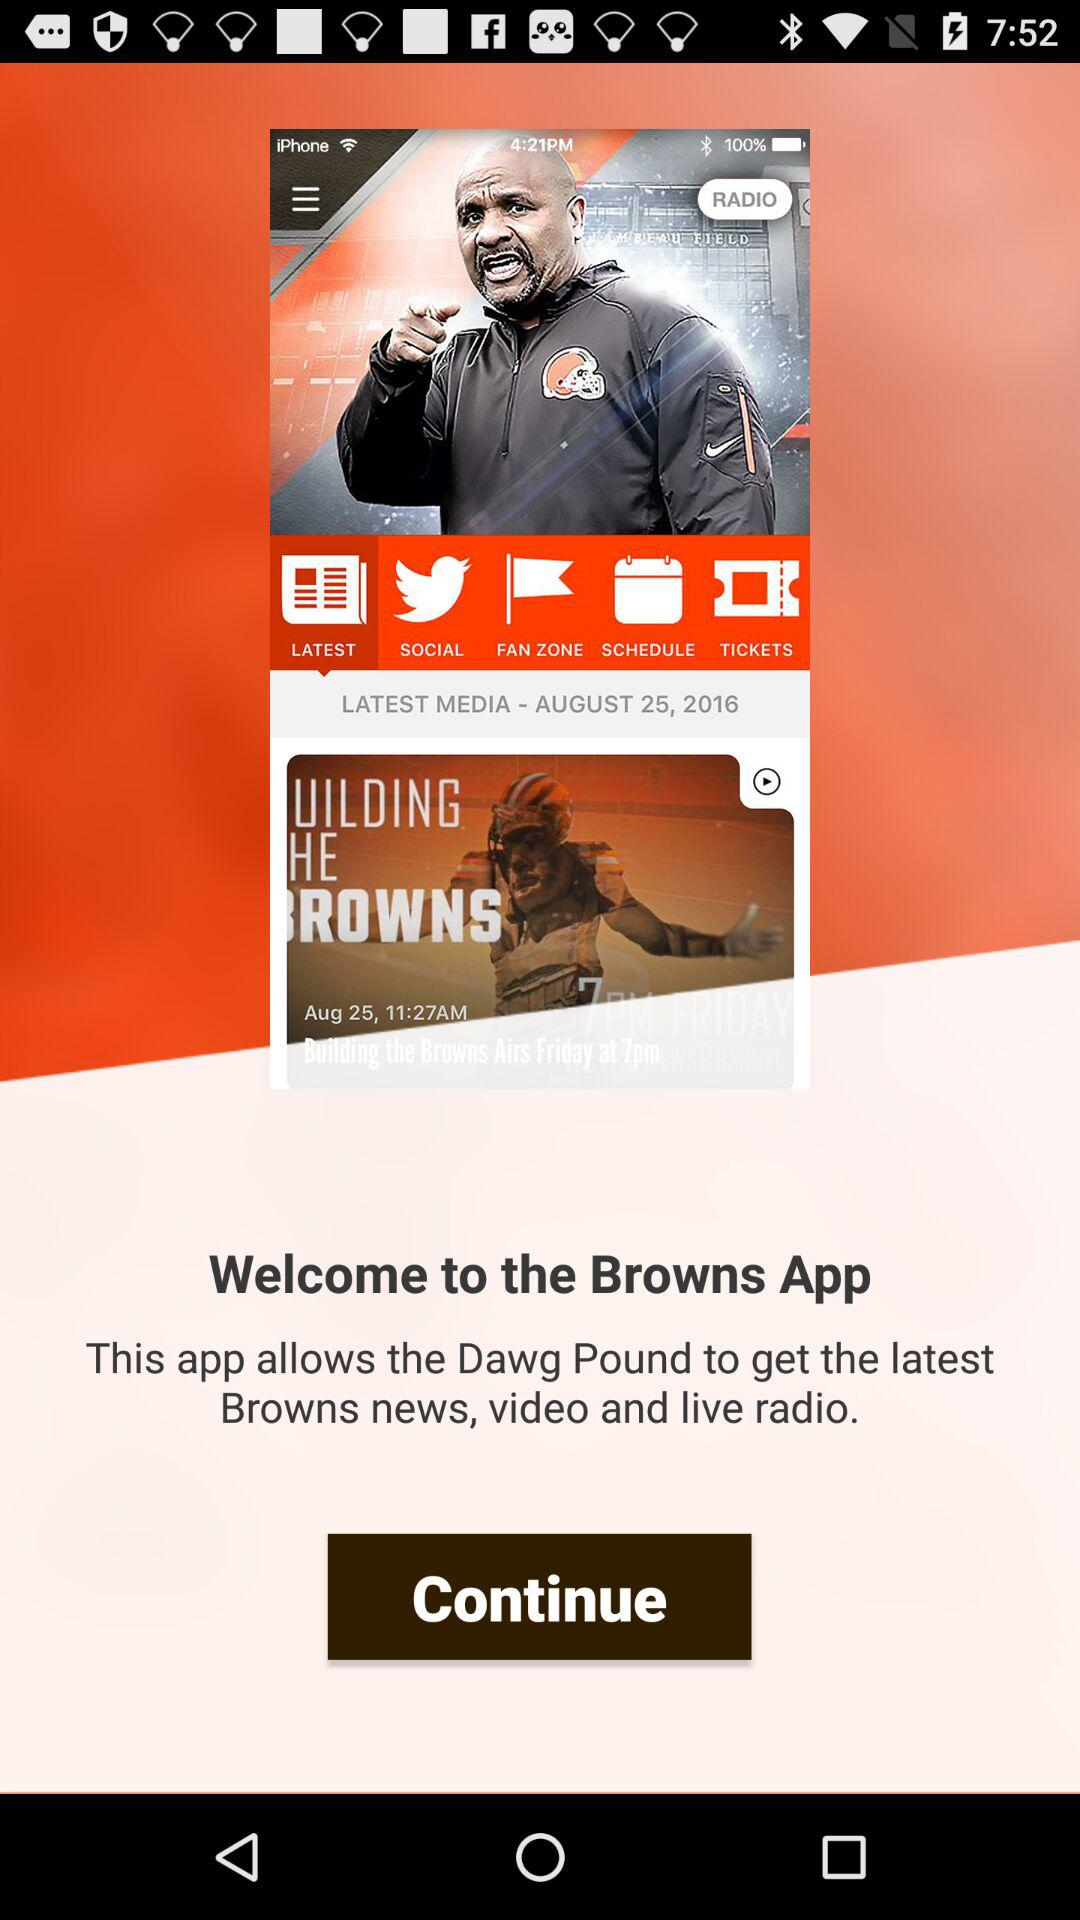What date is mentioned? The mentioned date is August 25, 2016. 